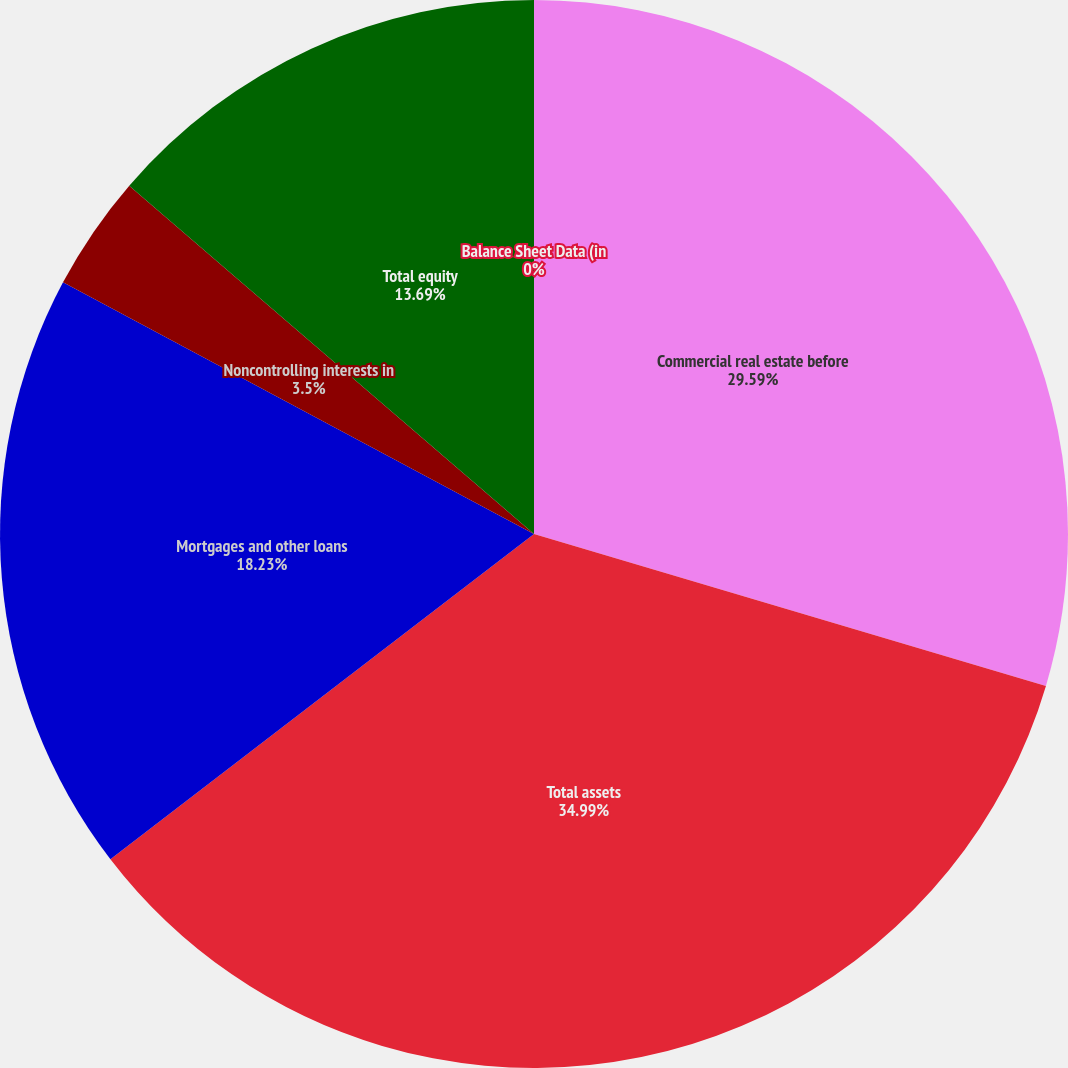Convert chart to OTSL. <chart><loc_0><loc_0><loc_500><loc_500><pie_chart><fcel>Balance Sheet Data (in<fcel>Commercial real estate before<fcel>Total assets<fcel>Mortgages and other loans<fcel>Noncontrolling interests in<fcel>Total equity<nl><fcel>0.0%<fcel>29.59%<fcel>34.99%<fcel>18.23%<fcel>3.5%<fcel>13.69%<nl></chart> 